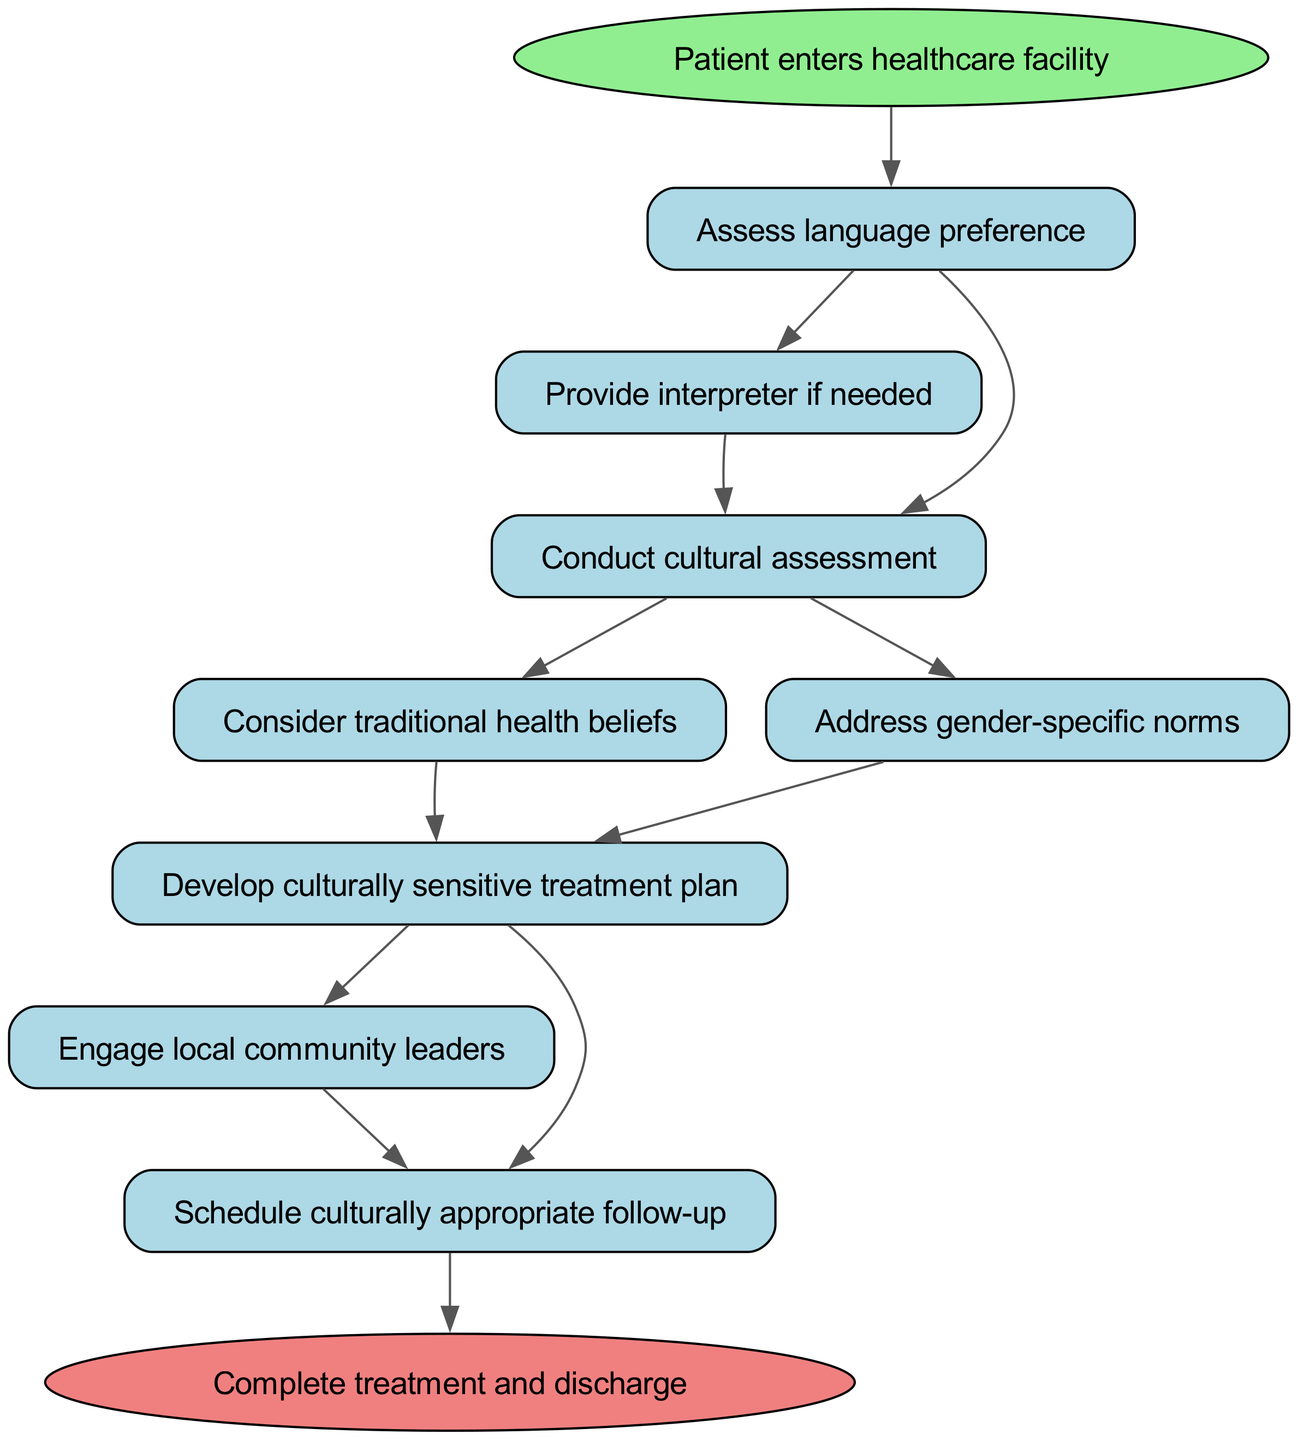What is the starting point of the pathway? The pathway begins at the node labeled "Patient enters healthcare facility." This node serves as the entry point for the diagram, indicating where the clinical process starts.
Answer: Patient enters healthcare facility How many nodes are in the diagram? To determine the number of nodes, I count each distinct node in the diagram, which includes start, language, interpreter, cultural_assessment, traditional_beliefs, gender_norms, treatment_plan, community_involvement, follow_up, and end. This totals 10 nodes.
Answer: 10 What happens after the "Assess language preference" step? After the "Assess language preference" step, if an interpreter is needed, the next step is "Provide interpreter if needed." If an interpreter is not needed, the next step is "Conduct cultural assessment."
Answer: Provide interpreter if needed or Conduct cultural assessment Which step follows "Develop culturally sensitive treatment plan"? The step that follows "Develop culturally sensitive treatment plan" is "Engage local community leaders." This connection indicates that after creating the treatment plan, engaging with community leaders is the next logical step.
Answer: Engage local community leaders What two assessments are conducted after "Assess language preference"? After "Assess language preference," both "Provide interpreter if needed" and "Conduct cultural assessment" are conducted. These assessments ensure effective communication and cultural understanding in the healthcare process.
Answer: Provide interpreter if needed, Conduct cultural assessment What is the endpoint of the clinical pathway? The endpoint of the clinical pathway is "Complete treatment and discharge." This indicates the final outcome of the healthcare process as represented in the diagram.
Answer: Complete treatment and discharge What specific norms are addressed after the cultural assessment? After the cultural assessment, both "Consider traditional health beliefs" and "Address gender-specific norms" are addressed. This shows the multifaceted approach to cultural sensitivity in treatment planning.
Answer: Consider traditional health beliefs and Address gender-specific norms How does the pathway ensure community involvement? Community involvement is ensured through the step "Engage local community leaders," which is connected to the earlier step "Develop culturally sensitive treatment plan." This means that community perspectives are considered in the treatment strategy.
Answer: Engage local community leaders 